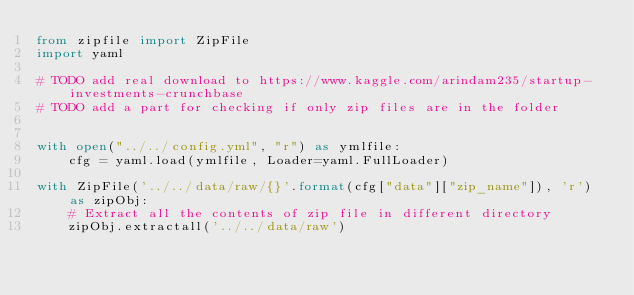<code> <loc_0><loc_0><loc_500><loc_500><_Python_>from zipfile import ZipFile
import yaml

# TODO add real download to https://www.kaggle.com/arindam235/startup-investments-crunchbase
# TODO add a part for checking if only zip files are in the folder


with open("../../config.yml", "r") as ymlfile:
    cfg = yaml.load(ymlfile, Loader=yaml.FullLoader)

with ZipFile('../../data/raw/{}'.format(cfg["data"]["zip_name"]), 'r') as zipObj:
    # Extract all the contents of zip file in different directory
    zipObj.extractall('../../data/raw')
</code> 